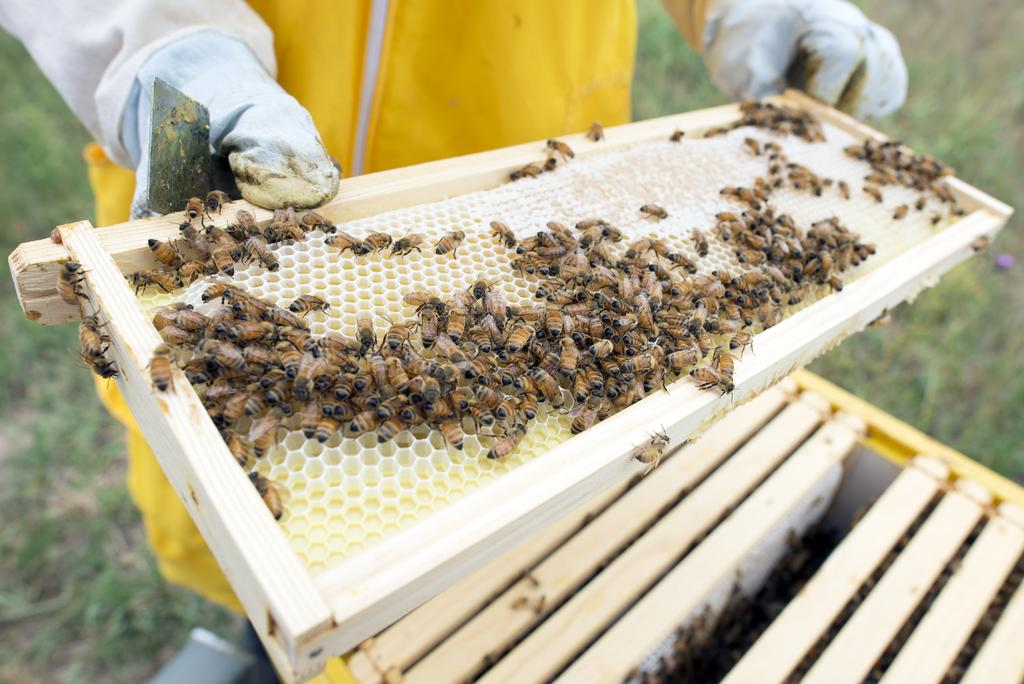What can be seen in the image? There is a person in the image. Can you describe the person's appearance? The person's face is not visible in the image. What is the person holding in the image? The person is holding a beekeeping slate. What else is present in the image? There is a box in the bottom right of the image. How many ducks are swimming in the water near the person in the image? There are no ducks present in the image. What type of thrill can be experienced by the person in the image? The image does not provide information about any specific thrill or activity the person might be experiencing. 